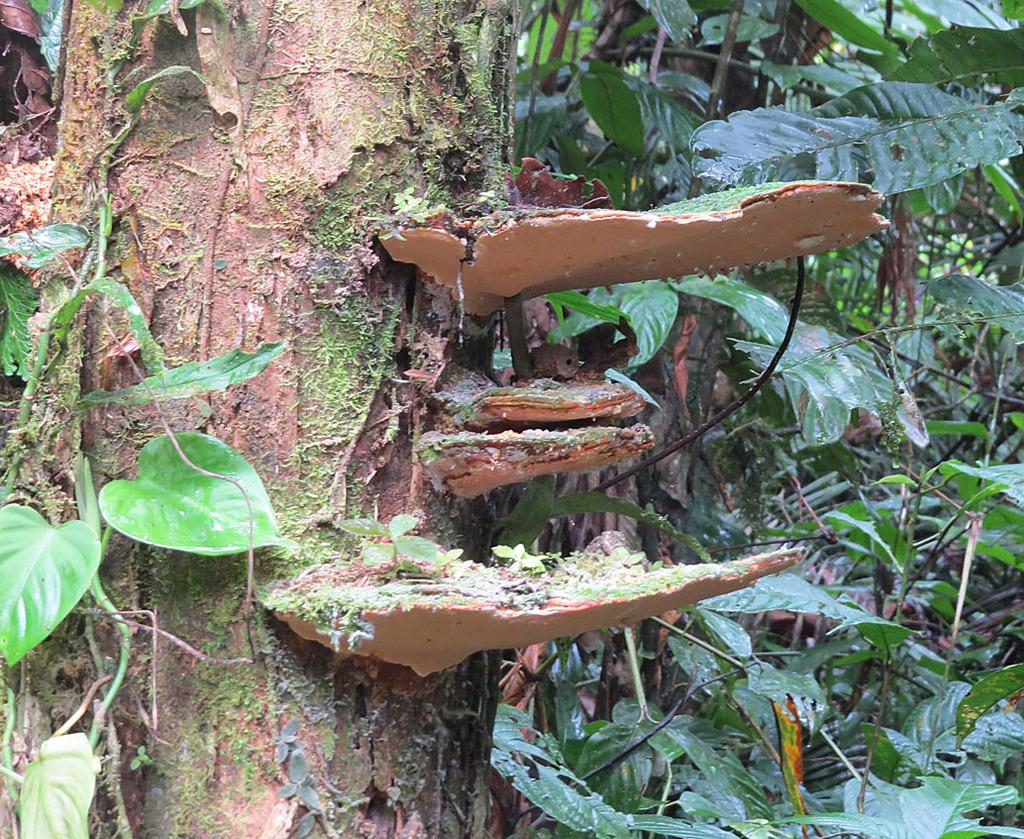What object is the main focus of the image? There is a branch in the image. Can you describe the appearance of the branch? The branch is brown in color. What can be seen in the background of the image? There are trees visible in the background of the image. How many sheep are present in the image? There are no sheep present in the image; it features a branch and trees in the background. What type of control is being exercised in the image? There is no control being exercised in the image; it is a still image of a branch and trees. 